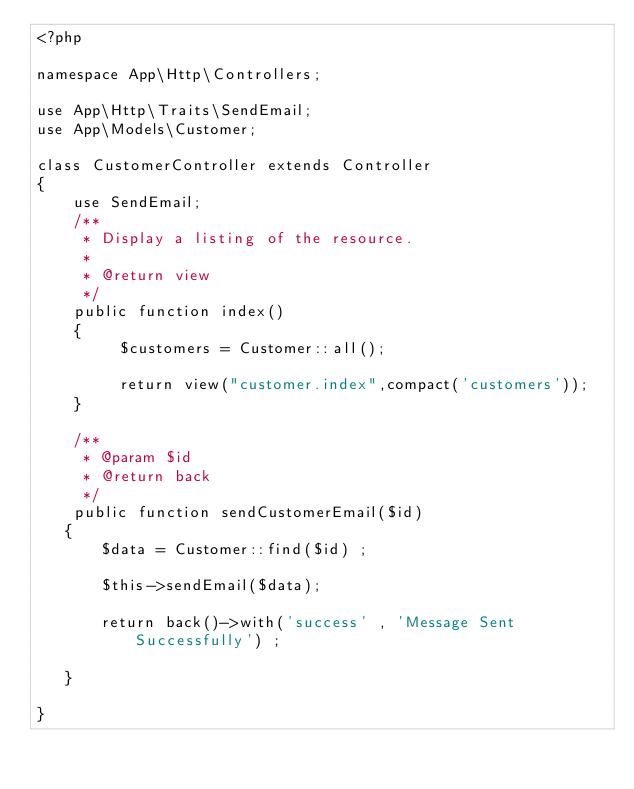<code> <loc_0><loc_0><loc_500><loc_500><_PHP_><?php

namespace App\Http\Controllers;

use App\Http\Traits\SendEmail;
use App\Models\Customer;

class CustomerController extends Controller
{
    use SendEmail;
    /**
     * Display a listing of the resource.
     *
     * @return view
     */
    public function index()
    {
         $customers = Customer::all();

         return view("customer.index",compact('customers'));
    }

    /**
     * @param $id
     * @return back
     */
    public function sendCustomerEmail($id)
   {
       $data = Customer::find($id) ;

       $this->sendEmail($data);

       return back()->with('success' , 'Message Sent Successfully') ;

   }

}
</code> 